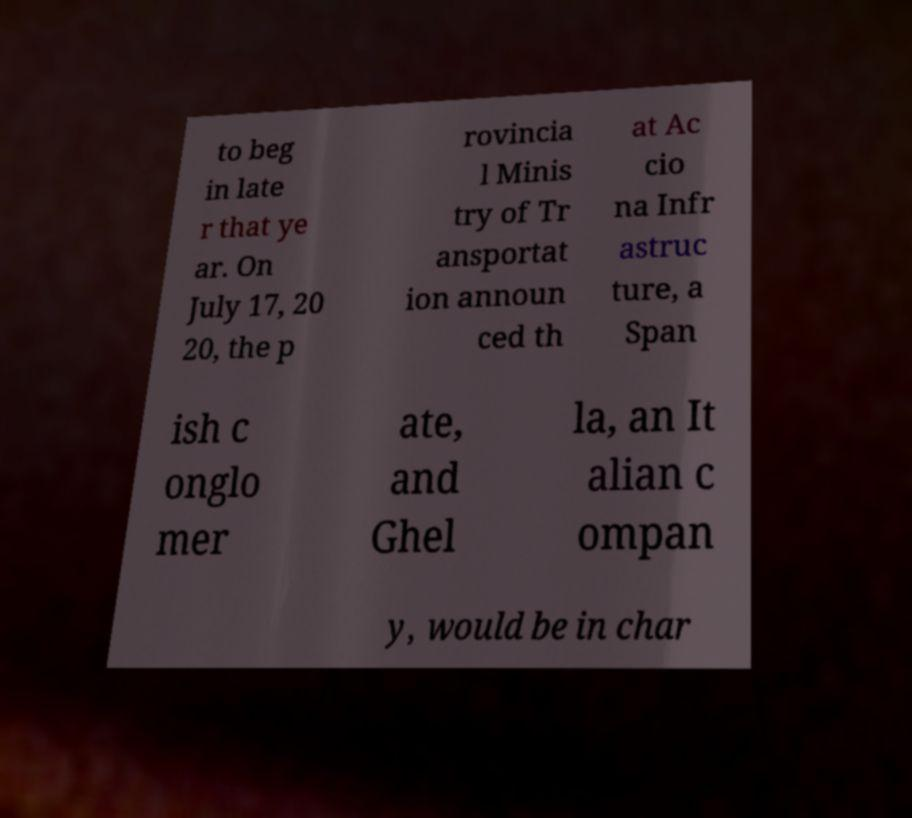For documentation purposes, I need the text within this image transcribed. Could you provide that? to beg in late r that ye ar. On July 17, 20 20, the p rovincia l Minis try of Tr ansportat ion announ ced th at Ac cio na Infr astruc ture, a Span ish c onglo mer ate, and Ghel la, an It alian c ompan y, would be in char 